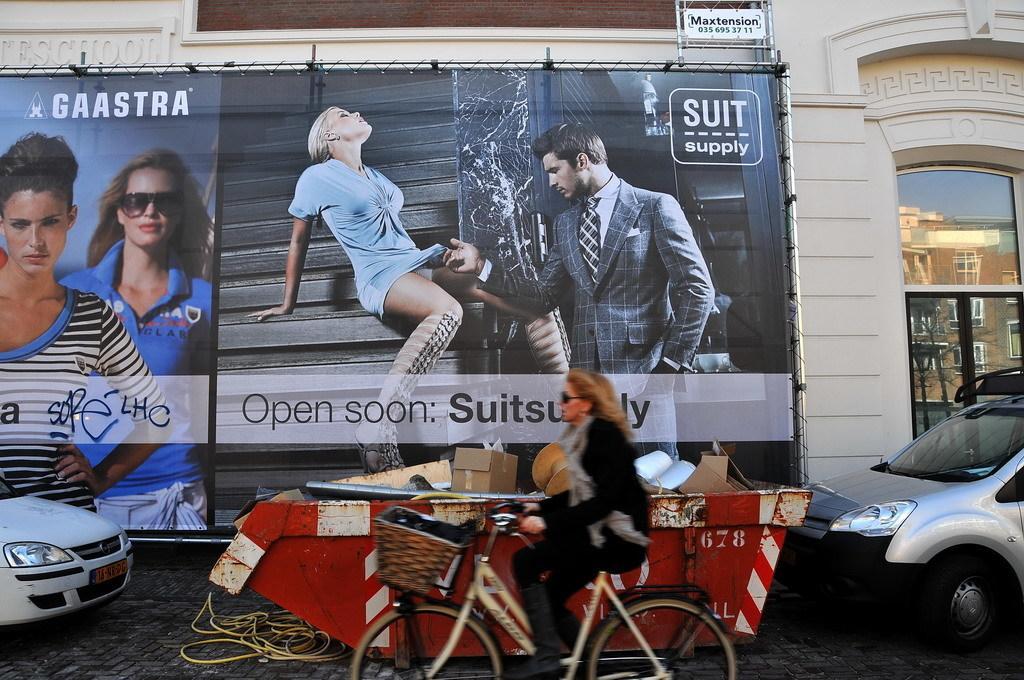Can you describe this image briefly? In the middle a woman riding a bicycle at the bottom. In the left bottom and right bottom two cars are there which are half visible. In the left middle, a poster is there. In the right and top a building is visible of white in color. This image is taken during day time on the road. 